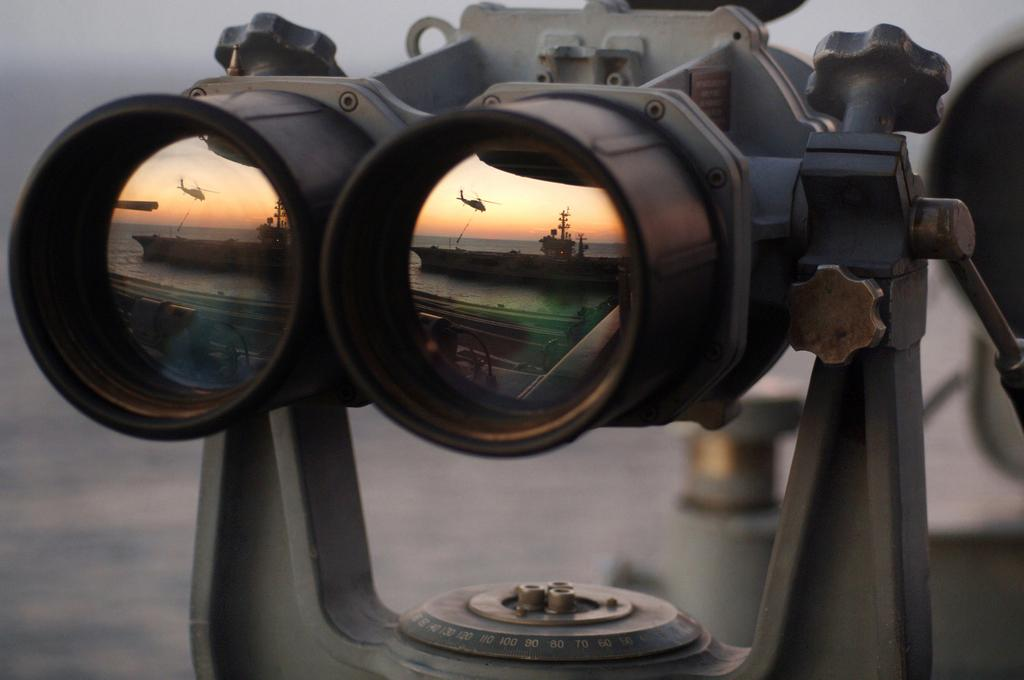What is the main object in the image? There is a pair of binoculars in the image. What might someone use the binoculars for? Someone might use the binoculars for observing distant objects or scenery. How many bikes are parked next to the binoculars in the image? There are no bikes present in the image; it only features a pair of binoculars. What type of snake can be seen slithering on the ground in the image? There is no snake present in the image; it only features a pair of binoculars. 